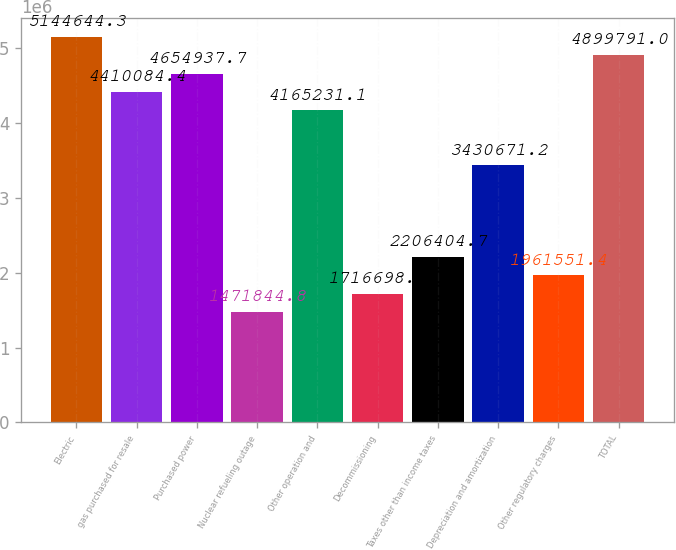Convert chart to OTSL. <chart><loc_0><loc_0><loc_500><loc_500><bar_chart><fcel>Electric<fcel>gas purchased for resale<fcel>Purchased power<fcel>Nuclear refueling outage<fcel>Other operation and<fcel>Decommissioning<fcel>Taxes other than income taxes<fcel>Depreciation and amortization<fcel>Other regulatory charges<fcel>TOTAL<nl><fcel>5.14464e+06<fcel>4.41008e+06<fcel>4.65494e+06<fcel>1.47184e+06<fcel>4.16523e+06<fcel>1.7167e+06<fcel>2.2064e+06<fcel>3.43067e+06<fcel>1.96155e+06<fcel>4.89979e+06<nl></chart> 